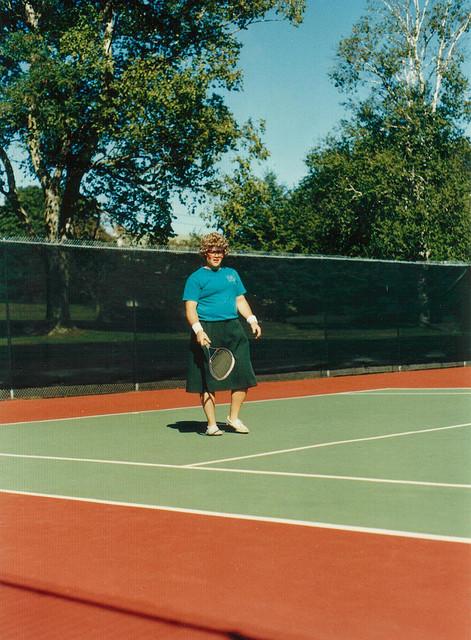Does the woman wear traditional tennis clothing?
Concise answer only. No. Why is the outfit odd?
Short answer required. Yes. Are there buildings behind the woman?
Write a very short answer. No. Is the tennis player returning the ball?
Keep it brief. No. How many tennis rackets is this woman holding?
Quick response, please. 1. What color is the court?
Give a very brief answer. Green. Does the player appear to be in shape?
Write a very short answer. No. 